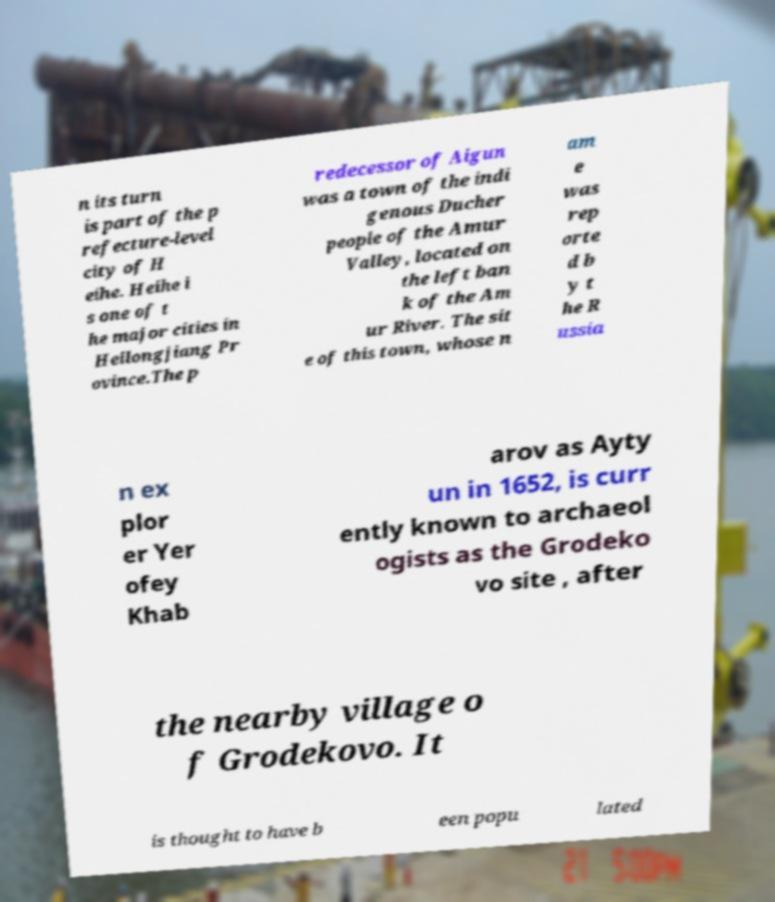Could you assist in decoding the text presented in this image and type it out clearly? n its turn is part of the p refecture-level city of H eihe. Heihe i s one of t he major cities in Heilongjiang Pr ovince.The p redecessor of Aigun was a town of the indi genous Ducher people of the Amur Valley, located on the left ban k of the Am ur River. The sit e of this town, whose n am e was rep orte d b y t he R ussia n ex plor er Yer ofey Khab arov as Ayty un in 1652, is curr ently known to archaeol ogists as the Grodeko vo site , after the nearby village o f Grodekovo. It is thought to have b een popu lated 